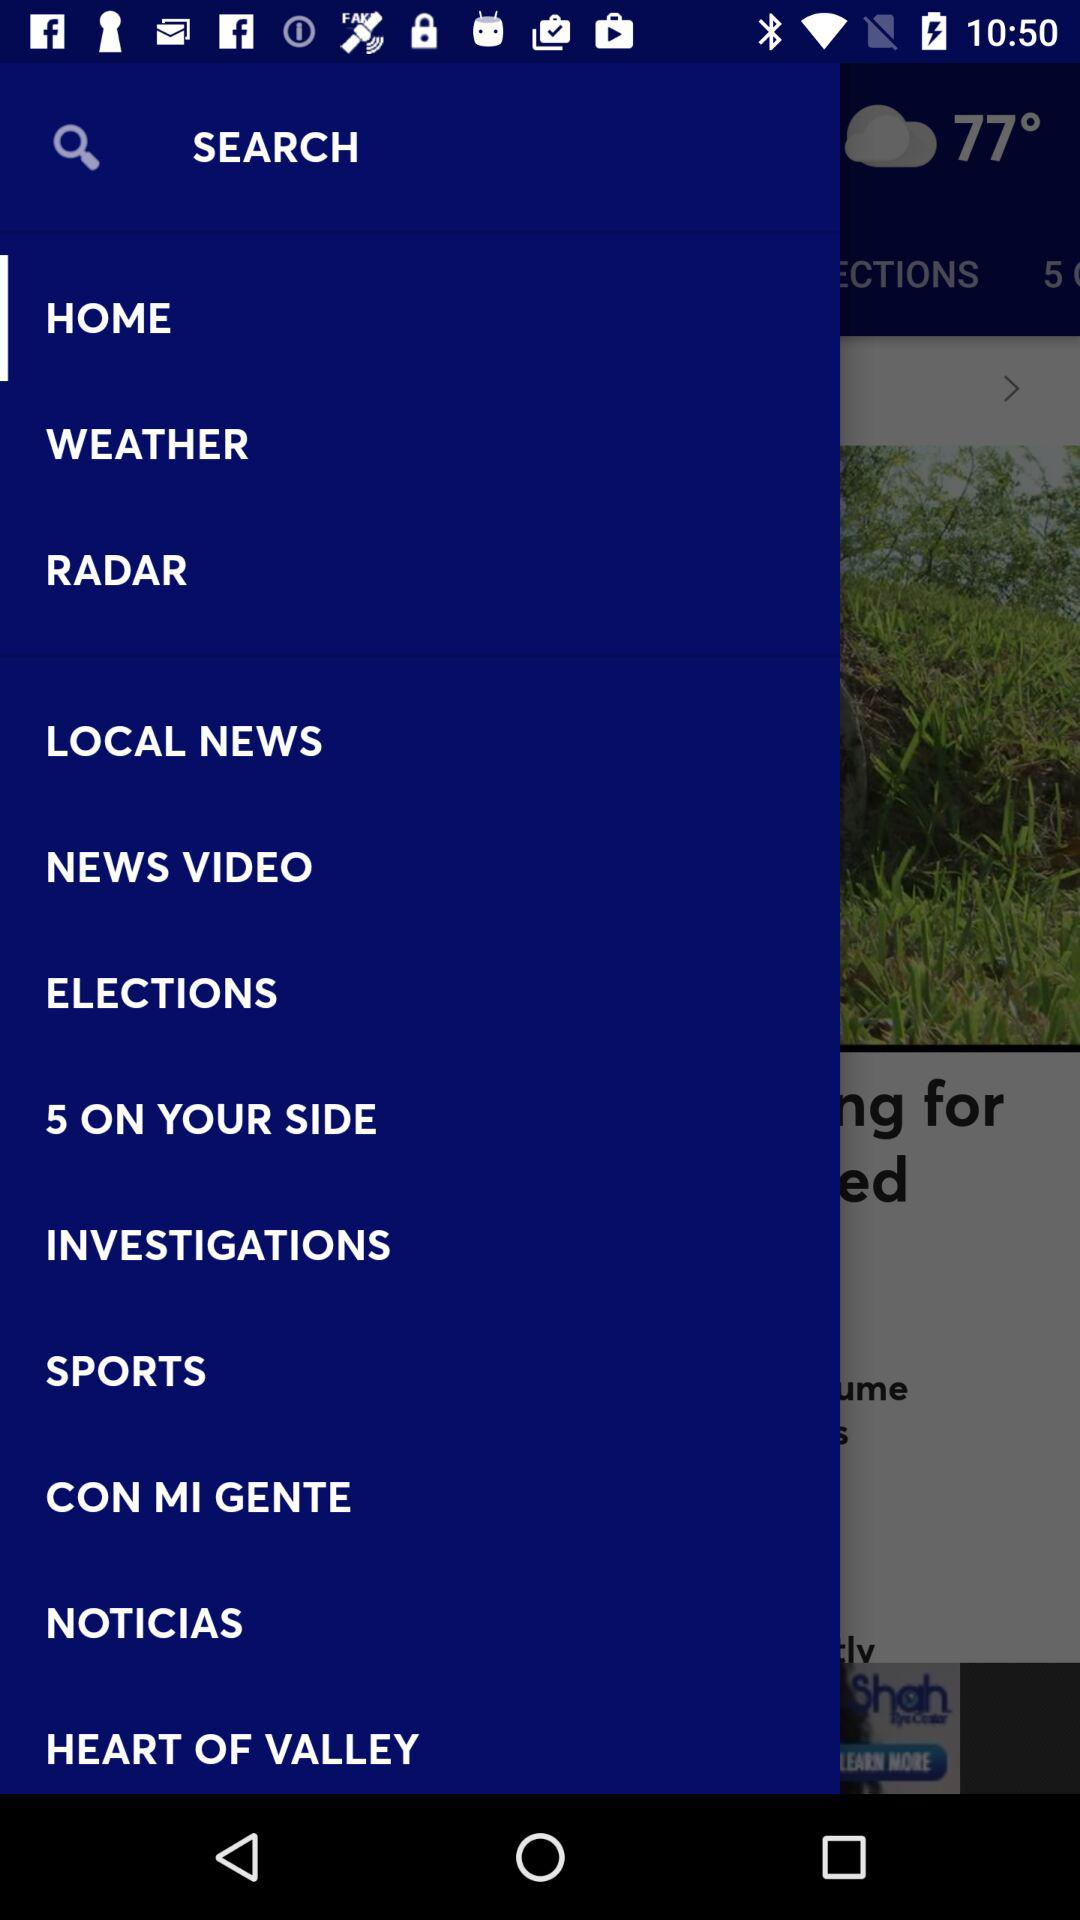What is the given temperature? The given temperature is 77 degrees. 